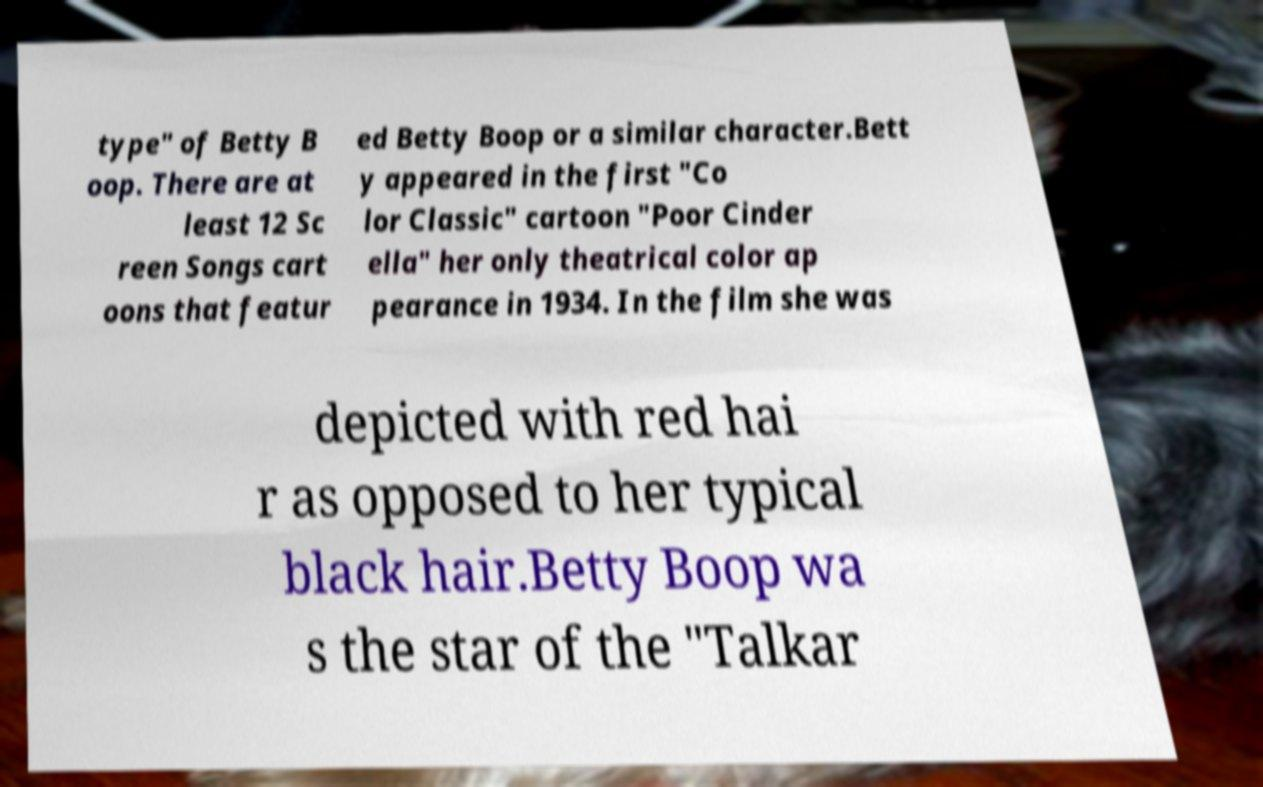Please identify and transcribe the text found in this image. type" of Betty B oop. There are at least 12 Sc reen Songs cart oons that featur ed Betty Boop or a similar character.Bett y appeared in the first "Co lor Classic" cartoon "Poor Cinder ella" her only theatrical color ap pearance in 1934. In the film she was depicted with red hai r as opposed to her typical black hair.Betty Boop wa s the star of the "Talkar 